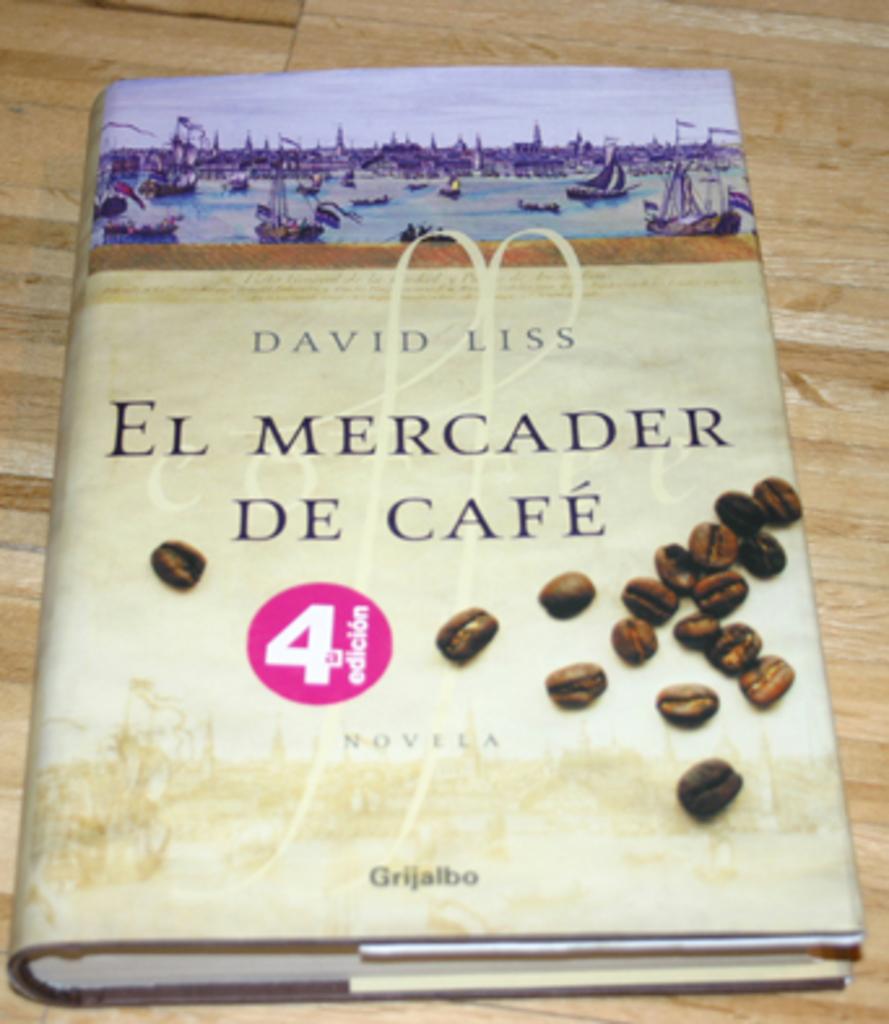Who wrote, "el mercader de cafe"?
Give a very brief answer. David liss. What is the title of this novel?
Ensure brevity in your answer.  El mercader de cafe. 